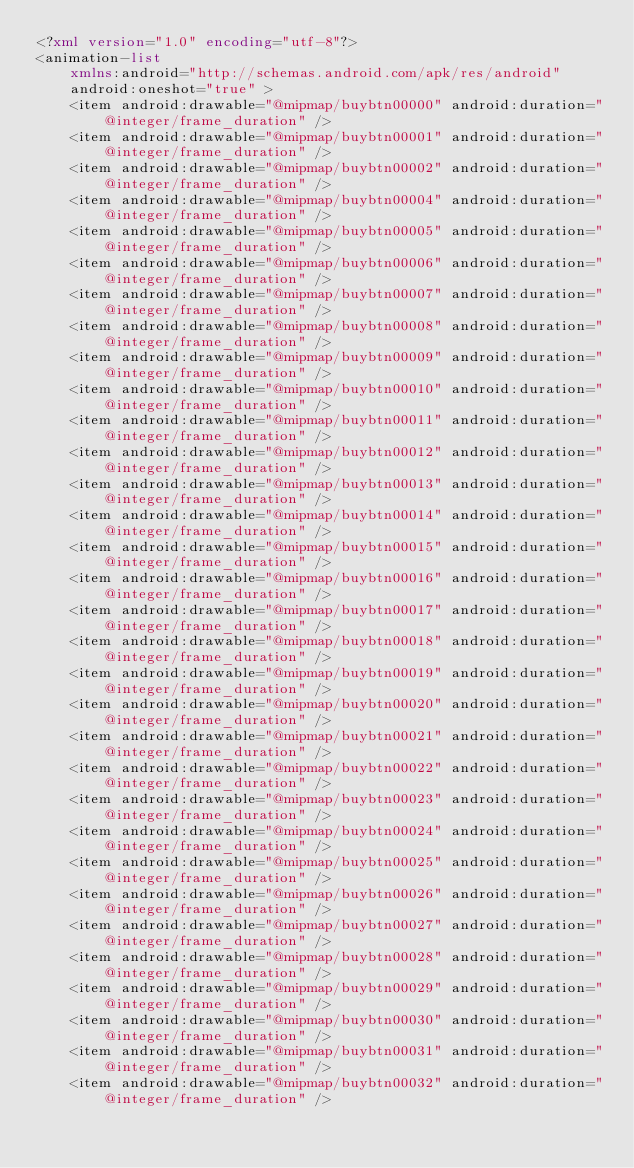Convert code to text. <code><loc_0><loc_0><loc_500><loc_500><_XML_><?xml version="1.0" encoding="utf-8"?>
<animation-list
    xmlns:android="http://schemas.android.com/apk/res/android"
    android:oneshot="true" >
    <item android:drawable="@mipmap/buybtn00000" android:duration="@integer/frame_duration" />
    <item android:drawable="@mipmap/buybtn00001" android:duration="@integer/frame_duration" />
    <item android:drawable="@mipmap/buybtn00002" android:duration="@integer/frame_duration" />
    <item android:drawable="@mipmap/buybtn00004" android:duration="@integer/frame_duration" />
    <item android:drawable="@mipmap/buybtn00005" android:duration="@integer/frame_duration" />
    <item android:drawable="@mipmap/buybtn00006" android:duration="@integer/frame_duration" />
    <item android:drawable="@mipmap/buybtn00007" android:duration="@integer/frame_duration" />
    <item android:drawable="@mipmap/buybtn00008" android:duration="@integer/frame_duration" />
    <item android:drawable="@mipmap/buybtn00009" android:duration="@integer/frame_duration" />
    <item android:drawable="@mipmap/buybtn00010" android:duration="@integer/frame_duration" />
    <item android:drawable="@mipmap/buybtn00011" android:duration="@integer/frame_duration" />
    <item android:drawable="@mipmap/buybtn00012" android:duration="@integer/frame_duration" />
    <item android:drawable="@mipmap/buybtn00013" android:duration="@integer/frame_duration" />
    <item android:drawable="@mipmap/buybtn00014" android:duration="@integer/frame_duration" />
    <item android:drawable="@mipmap/buybtn00015" android:duration="@integer/frame_duration" />
    <item android:drawable="@mipmap/buybtn00016" android:duration="@integer/frame_duration" />
    <item android:drawable="@mipmap/buybtn00017" android:duration="@integer/frame_duration" />
    <item android:drawable="@mipmap/buybtn00018" android:duration="@integer/frame_duration" />
    <item android:drawable="@mipmap/buybtn00019" android:duration="@integer/frame_duration" />
    <item android:drawable="@mipmap/buybtn00020" android:duration="@integer/frame_duration" />
    <item android:drawable="@mipmap/buybtn00021" android:duration="@integer/frame_duration" />
    <item android:drawable="@mipmap/buybtn00022" android:duration="@integer/frame_duration" />
    <item android:drawable="@mipmap/buybtn00023" android:duration="@integer/frame_duration" />
    <item android:drawable="@mipmap/buybtn00024" android:duration="@integer/frame_duration" />
    <item android:drawable="@mipmap/buybtn00025" android:duration="@integer/frame_duration" />
    <item android:drawable="@mipmap/buybtn00026" android:duration="@integer/frame_duration" />
    <item android:drawable="@mipmap/buybtn00027" android:duration="@integer/frame_duration" />
    <item android:drawable="@mipmap/buybtn00028" android:duration="@integer/frame_duration" />
    <item android:drawable="@mipmap/buybtn00029" android:duration="@integer/frame_duration" />
    <item android:drawable="@mipmap/buybtn00030" android:duration="@integer/frame_duration" />
    <item android:drawable="@mipmap/buybtn00031" android:duration="@integer/frame_duration" />
    <item android:drawable="@mipmap/buybtn00032" android:duration="@integer/frame_duration" /></code> 